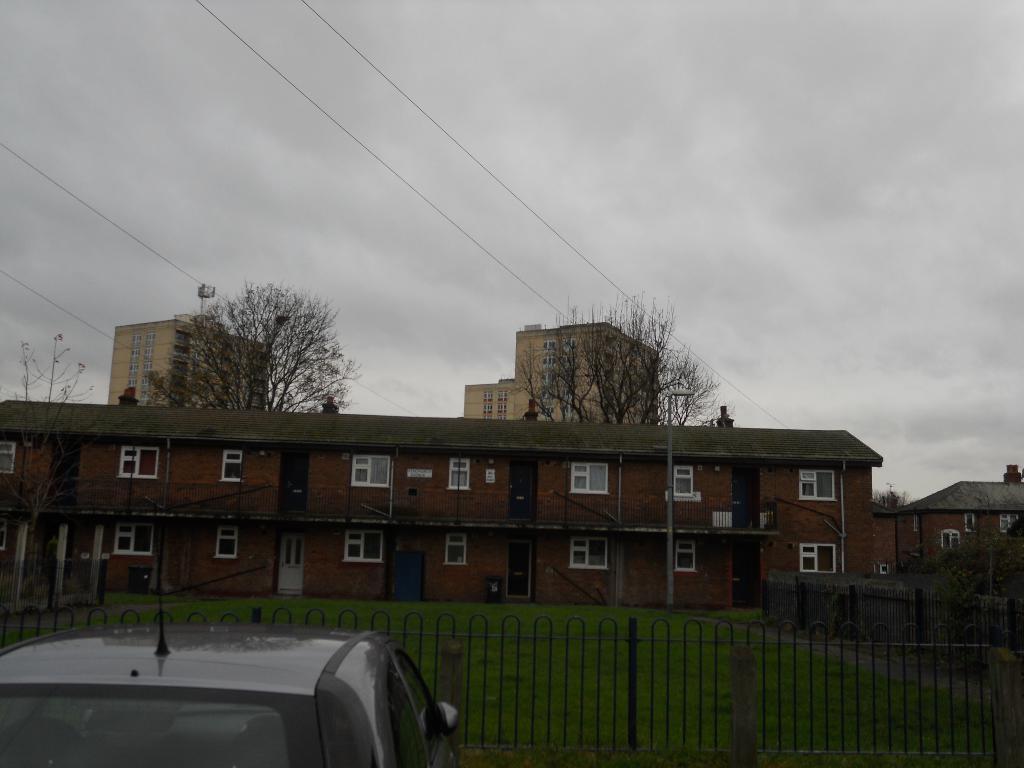In one or two sentences, can you explain what this image depicts? In this image in the center there are buildings, trees, poles, and at the bottom there is grass and car. At the top the sky is cloudy and also we could see wires. 